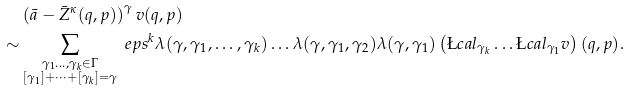Convert formula to latex. <formula><loc_0><loc_0><loc_500><loc_500>& \left ( \bar { a } - \bar { Z } ^ { \kappa } ( q , p ) \right ) ^ { \gamma } v ( q , p ) \\ \sim & \sum _ { \substack { \gamma _ { 1 } \dots , \gamma _ { k } \in \Gamma \\ [ \gamma _ { 1 } ] + \dots + [ \gamma _ { k } ] = \gamma } } \ e p s ^ { k } \lambda ( \gamma , \gamma _ { 1 } , \dots , \gamma _ { k } ) \dots \lambda ( \gamma , \gamma _ { 1 } , \gamma _ { 2 } ) \lambda ( \gamma , \gamma _ { 1 } ) \left ( \L c a l _ { \gamma _ { k } } \dots \L c a l _ { \gamma _ { 1 } } v \right ) ( q , p ) .</formula> 